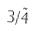<formula> <loc_0><loc_0><loc_500><loc_500>3 / \tilde { 4 }</formula> 